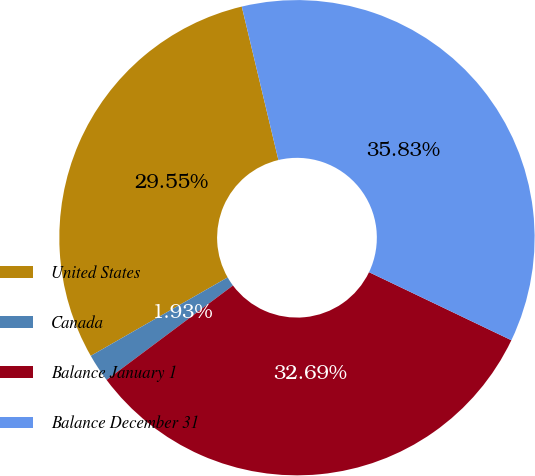Convert chart to OTSL. <chart><loc_0><loc_0><loc_500><loc_500><pie_chart><fcel>United States<fcel>Canada<fcel>Balance January 1<fcel>Balance December 31<nl><fcel>29.55%<fcel>1.93%<fcel>32.69%<fcel>35.83%<nl></chart> 